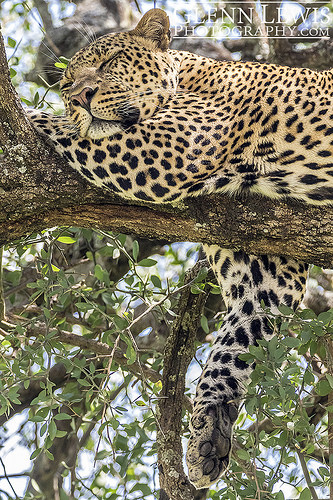<image>
Is the jaguar on the tree branch? Yes. Looking at the image, I can see the jaguar is positioned on top of the tree branch, with the tree branch providing support. Is there a cheetah on the tree? Yes. Looking at the image, I can see the cheetah is positioned on top of the tree, with the tree providing support. 